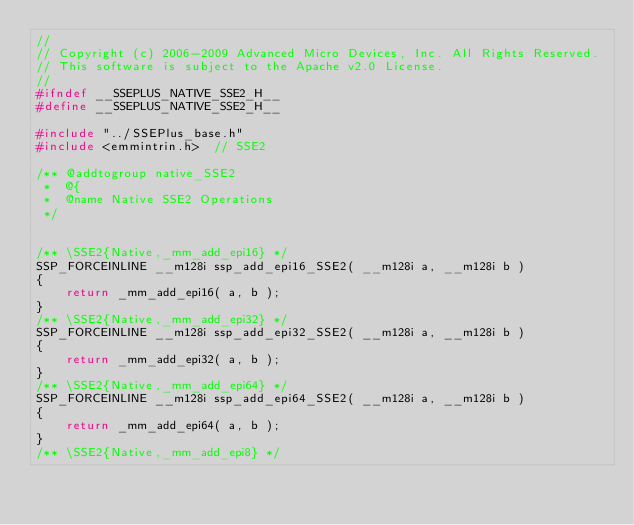<code> <loc_0><loc_0><loc_500><loc_500><_C_>//
// Copyright (c) 2006-2009 Advanced Micro Devices, Inc. All Rights Reserved.
// This software is subject to the Apache v2.0 License.
//
#ifndef __SSEPLUS_NATIVE_SSE2_H__
#define __SSEPLUS_NATIVE_SSE2_H__

#include "../SSEPlus_base.h"
#include <emmintrin.h>  // SSE2

/** @addtogroup native_SSE2  
 *  @{ 
 *  @name Native SSE2 Operations
 */


/** \SSE2{Native,_mm_add_epi16} */ 
SSP_FORCEINLINE __m128i ssp_add_epi16_SSE2( __m128i a, __m128i b )
{
    return _mm_add_epi16( a, b );
}
/** \SSE2{Native,_mm_add_epi32} */ 
SSP_FORCEINLINE __m128i ssp_add_epi32_SSE2( __m128i a, __m128i b )
{
    return _mm_add_epi32( a, b );
}
/** \SSE2{Native,_mm_add_epi64} */ 
SSP_FORCEINLINE __m128i ssp_add_epi64_SSE2( __m128i a, __m128i b )
{
    return _mm_add_epi64( a, b );
}
/** \SSE2{Native,_mm_add_epi8} */ </code> 